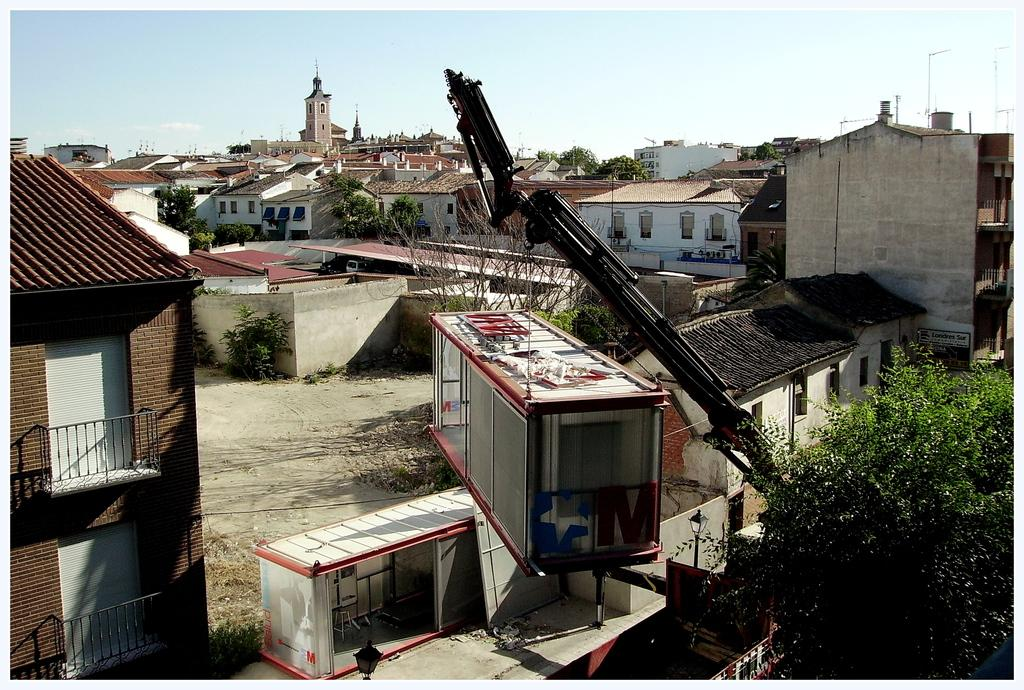What type of structures can be seen in the image? There are many buildings in the image. What other elements are present in the image besides buildings? There are trees in the image. Can you describe any machinery or equipment in the image? Yes, there is a crane in the image. What is the crane doing in the image? The crane is holding a container. What type of grain can be seen growing in the image? There is no grain visible in the image; it primarily features buildings, trees, and a crane holding a container. 